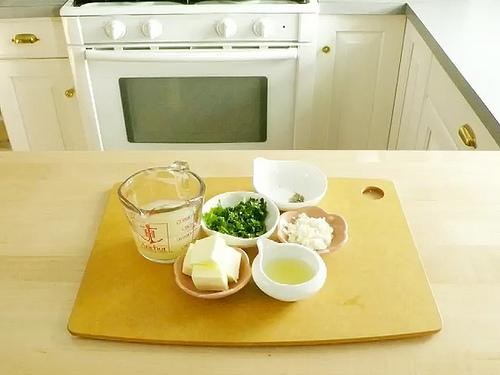Which one of these processes produced the spread here?

Choices:
A) eating
B) food prep
C) discarding
D) baking food prep 